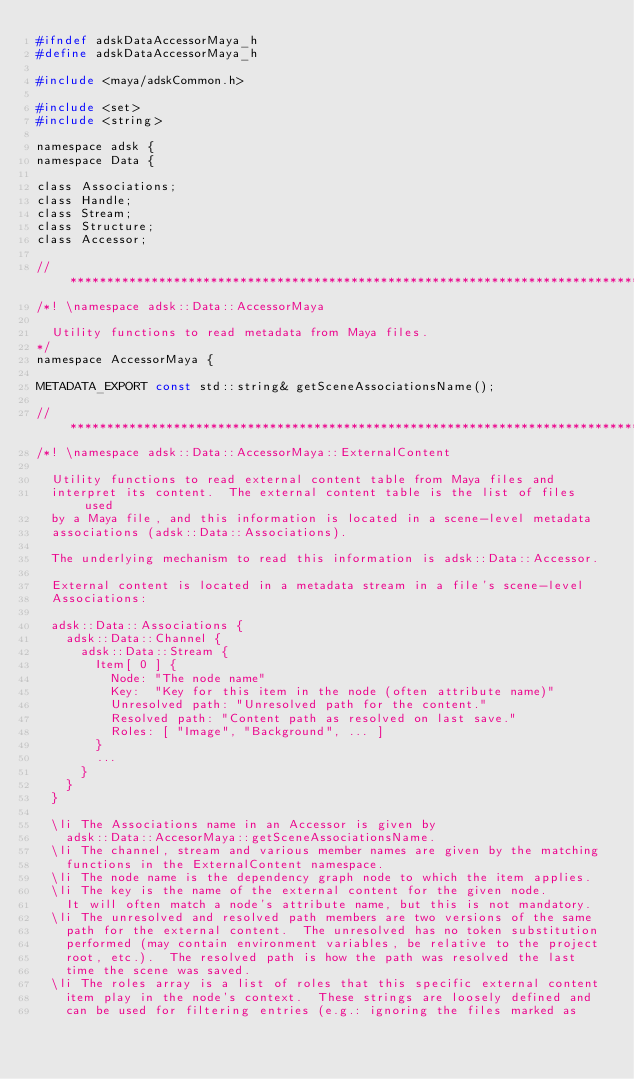<code> <loc_0><loc_0><loc_500><loc_500><_C_>#ifndef adskDataAccessorMaya_h
#define adskDataAccessorMaya_h

#include <maya/adskCommon.h>

#include <set>
#include <string>

namespace adsk {
namespace Data {

class Associations;
class Handle;
class Stream;
class Structure;
class Accessor;

// *****************************************************************************
/*! \namespace adsk::Data::AccessorMaya

	Utility functions to read metadata from Maya files.
*/
namespace AccessorMaya {

METADATA_EXPORT const std::string& getSceneAssociationsName();

// *****************************************************************************
/*! \namespace adsk::Data::AccessorMaya::ExternalContent

	Utility functions to read external content table from Maya files and
	interpret its content.  The external content table is the list of files used
	by a Maya file, and this information is located in a scene-level metadata
	associations (adsk::Data::Associations).

	The underlying mechanism to read this information is adsk::Data::Accessor.

	External content is located in a metadata stream in a file's scene-level
	Associations:

	adsk::Data::Associations {
		adsk::Data::Channel {
			adsk::Data::Stream {
				Item[ 0 ] {
					Node: "The node name"
					Key:  "Key for this item in the node (often attribute name)"
					Unresolved path: "Unresolved path for the content."
					Resolved path: "Content path as resolved on last save."
					Roles: [ "Image", "Background", ... ]
				}
				...
			}
		}
	}

	\li The Associations name in an Accessor is given by
		adsk::Data::AccesorMaya::getSceneAssociationsName.
	\li The channel, stream and various member names are given by the matching
		functions in the ExternalContent namespace.
	\li The node name is the dependency graph node to which the item applies.
	\li The key is the name of the external content for the given node.
		It will often match a node's attribute name, but this is not mandatory.
	\li The unresolved and resolved path members are two versions of the same
		path for the external content.  The unresolved has no token substitution
		performed (may contain environment variables, be relative to the project
		root, etc.).  The resolved path is how the path was resolved the last
		time the scene was saved.
	\li The roles array is a list of roles that this specific external content
		item play in the node's context.  These strings are loosely defined and
		can be used for filtering entries (e.g.: ignoring the files marked as</code> 